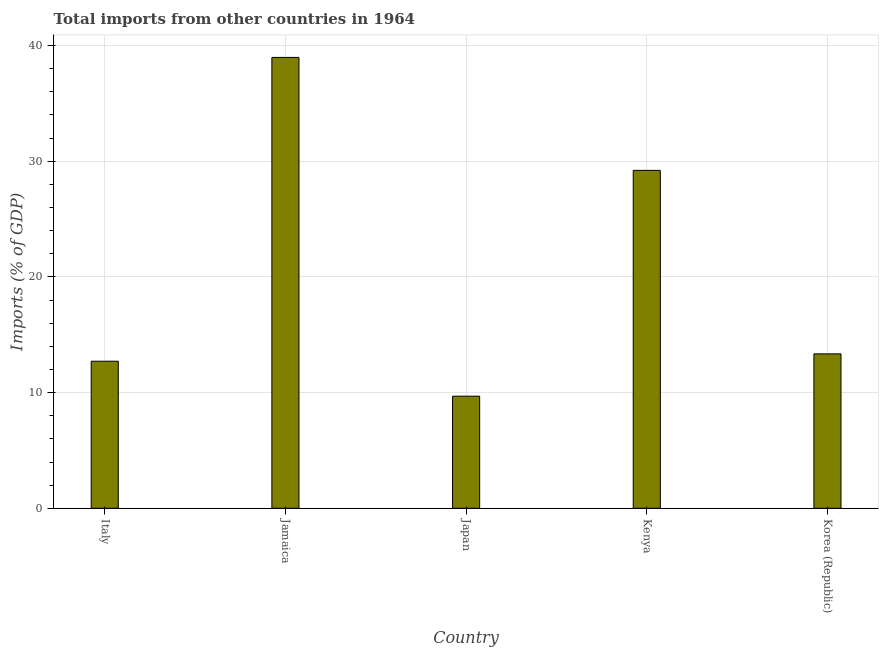Does the graph contain any zero values?
Give a very brief answer. No. Does the graph contain grids?
Give a very brief answer. Yes. What is the title of the graph?
Your answer should be very brief. Total imports from other countries in 1964. What is the label or title of the Y-axis?
Make the answer very short. Imports (% of GDP). What is the total imports in Jamaica?
Your answer should be compact. 38.98. Across all countries, what is the maximum total imports?
Keep it short and to the point. 38.98. Across all countries, what is the minimum total imports?
Provide a short and direct response. 9.69. In which country was the total imports maximum?
Your answer should be compact. Jamaica. In which country was the total imports minimum?
Offer a very short reply. Japan. What is the sum of the total imports?
Make the answer very short. 103.94. What is the difference between the total imports in Jamaica and Korea (Republic)?
Ensure brevity in your answer.  25.63. What is the average total imports per country?
Make the answer very short. 20.79. What is the median total imports?
Your answer should be very brief. 13.35. What is the ratio of the total imports in Jamaica to that in Kenya?
Provide a short and direct response. 1.33. Is the total imports in Kenya less than that in Korea (Republic)?
Your answer should be compact. No. What is the difference between the highest and the second highest total imports?
Provide a short and direct response. 9.77. What is the difference between the highest and the lowest total imports?
Your answer should be compact. 29.29. In how many countries, is the total imports greater than the average total imports taken over all countries?
Give a very brief answer. 2. How many bars are there?
Provide a succinct answer. 5. Are all the bars in the graph horizontal?
Make the answer very short. No. How many countries are there in the graph?
Offer a very short reply. 5. What is the difference between two consecutive major ticks on the Y-axis?
Offer a very short reply. 10. Are the values on the major ticks of Y-axis written in scientific E-notation?
Offer a terse response. No. What is the Imports (% of GDP) in Italy?
Provide a succinct answer. 12.71. What is the Imports (% of GDP) of Jamaica?
Ensure brevity in your answer.  38.98. What is the Imports (% of GDP) in Japan?
Your answer should be compact. 9.69. What is the Imports (% of GDP) in Kenya?
Make the answer very short. 29.21. What is the Imports (% of GDP) of Korea (Republic)?
Offer a terse response. 13.35. What is the difference between the Imports (% of GDP) in Italy and Jamaica?
Provide a short and direct response. -26.26. What is the difference between the Imports (% of GDP) in Italy and Japan?
Give a very brief answer. 3.02. What is the difference between the Imports (% of GDP) in Italy and Kenya?
Offer a very short reply. -16.5. What is the difference between the Imports (% of GDP) in Italy and Korea (Republic)?
Make the answer very short. -0.63. What is the difference between the Imports (% of GDP) in Jamaica and Japan?
Ensure brevity in your answer.  29.29. What is the difference between the Imports (% of GDP) in Jamaica and Kenya?
Offer a terse response. 9.77. What is the difference between the Imports (% of GDP) in Jamaica and Korea (Republic)?
Make the answer very short. 25.63. What is the difference between the Imports (% of GDP) in Japan and Kenya?
Provide a succinct answer. -19.52. What is the difference between the Imports (% of GDP) in Japan and Korea (Republic)?
Your response must be concise. -3.66. What is the difference between the Imports (% of GDP) in Kenya and Korea (Republic)?
Keep it short and to the point. 15.86. What is the ratio of the Imports (% of GDP) in Italy to that in Jamaica?
Provide a succinct answer. 0.33. What is the ratio of the Imports (% of GDP) in Italy to that in Japan?
Make the answer very short. 1.31. What is the ratio of the Imports (% of GDP) in Italy to that in Kenya?
Your answer should be very brief. 0.43. What is the ratio of the Imports (% of GDP) in Jamaica to that in Japan?
Keep it short and to the point. 4.02. What is the ratio of the Imports (% of GDP) in Jamaica to that in Kenya?
Your response must be concise. 1.33. What is the ratio of the Imports (% of GDP) in Jamaica to that in Korea (Republic)?
Ensure brevity in your answer.  2.92. What is the ratio of the Imports (% of GDP) in Japan to that in Kenya?
Make the answer very short. 0.33. What is the ratio of the Imports (% of GDP) in Japan to that in Korea (Republic)?
Your response must be concise. 0.73. What is the ratio of the Imports (% of GDP) in Kenya to that in Korea (Republic)?
Keep it short and to the point. 2.19. 